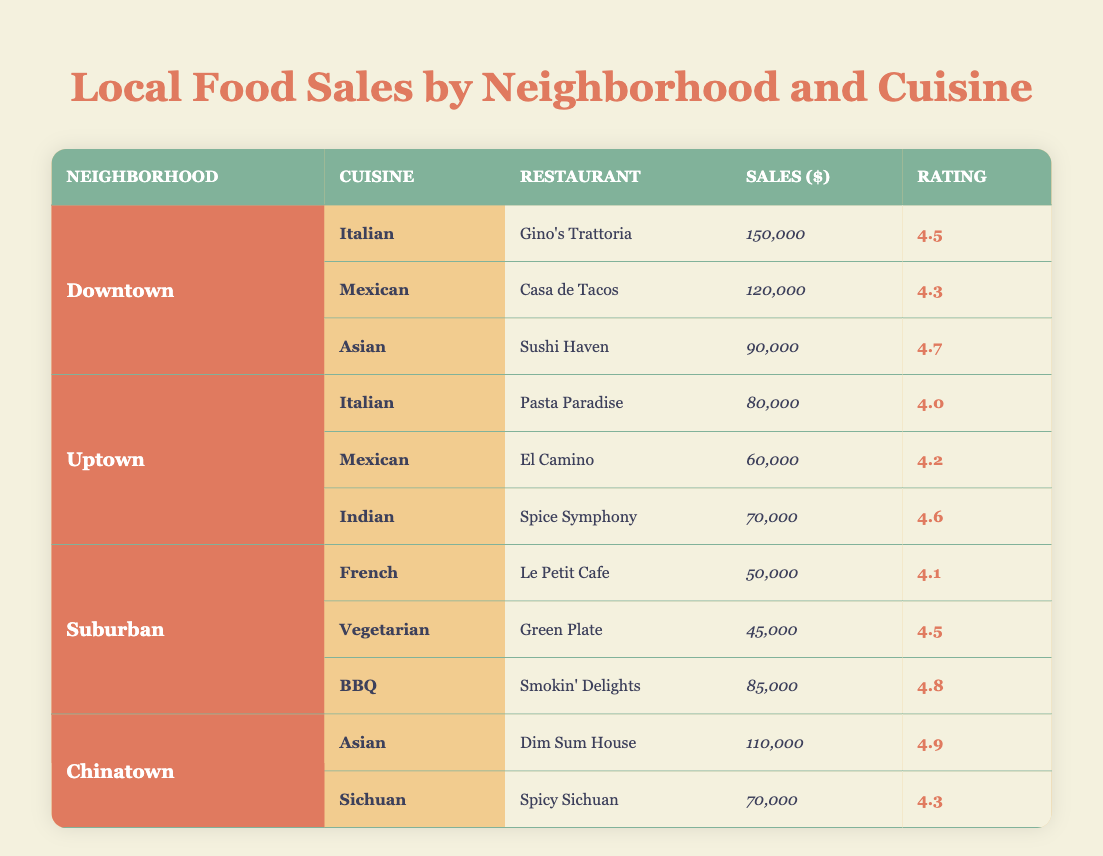What is the total sales amount from Italian restaurants in Downtown and Uptown? The sales from Italian restaurants in Downtown is 150,000 from Gino's Trattoria, and in Uptown, it is 80,000 from Pasta Paradise. Adding these two amounts gives total sales of 150,000 + 80,000 = 230,000.
Answer: 230,000 Which neighborhood has the highest-rated Asian restaurant, and what is its rating? In Chinatown, Dim Sum House has the highest rating of 4.9 for its Asian cuisine. None of the Asian restaurants in other neighborhoods exceeds this rating.
Answer: Chinatown, 4.9 Does the Suburban neighborhood have any restaurant with a sales figure exceeding 90,000? The highest sales in Suburban is from Smokin' Delights with a sales figure of 85,000, which does not exceed 90,000. Thus, the answer is no.
Answer: No What is the average sales amount of Mexican cuisine across all neighborhoods? The sales for Mexican cuisine are 120,000 in Downtown (Casa de Tacos), 60,000 in Uptown (El Camino), and there are no Mexican restaurants listed in Suburban or Chinatown. Summing these sales gives 120,000 + 60,000 = 180,000, and dividing by the two data points gives an average of 180,000 / 2 = 90,000.
Answer: 90,000 Which restaurant has the lowest sales in the table, and what is its sales figure? Among all listed restaurants, Green Plate in Suburban has the lowest sales at 45,000. Other restaurants have higher sales figures.
Answer: Green Plate, 45,000 Are there any Indian restaurants in the Downtown neighborhood? The table shows that Indian cuisine is represented only in Uptown with Spice Symphony. There are no Indian restaurants mentioned in Downtown.
Answer: No What is the total sales of BBQ restaurants in Suburban? The BBQ restaurant listed in Suburban is Smokin' Delights with sales of 85,000. Since it's the only BBQ establishment in that neighborhood, the total sales equals 85,000.
Answer: 85,000 Which cuisine has the best overall rating in the table? The highest rating recorded in the table is for the Asian cuisine at Dim Sum House in Chinatown with a rating of 4.9. All other cuisines have lower ratings, making Asian cuisine the best overall.
Answer: Asian, 4.9 What percentage of the total sales does Uptown contribute compared to the total sales across all neighborhoods? The total sales for Uptown are 80,000 (Italian) + 60,000 (Mexican) + 70,000 (Indian) = 210,000. Calculating total sales from all neighborhoods gives: 150,000 + 120,000 + 90,000 (Downtown) + 210,000 (Uptown) + 50,000 + 45,000 + 85,000 (Suburban) + 110,000 + 70,000 (Chinatown) = 1,020,000. Thus, 210,000 / 1,020,000 gives about 20.59%.
Answer: 20.59% 